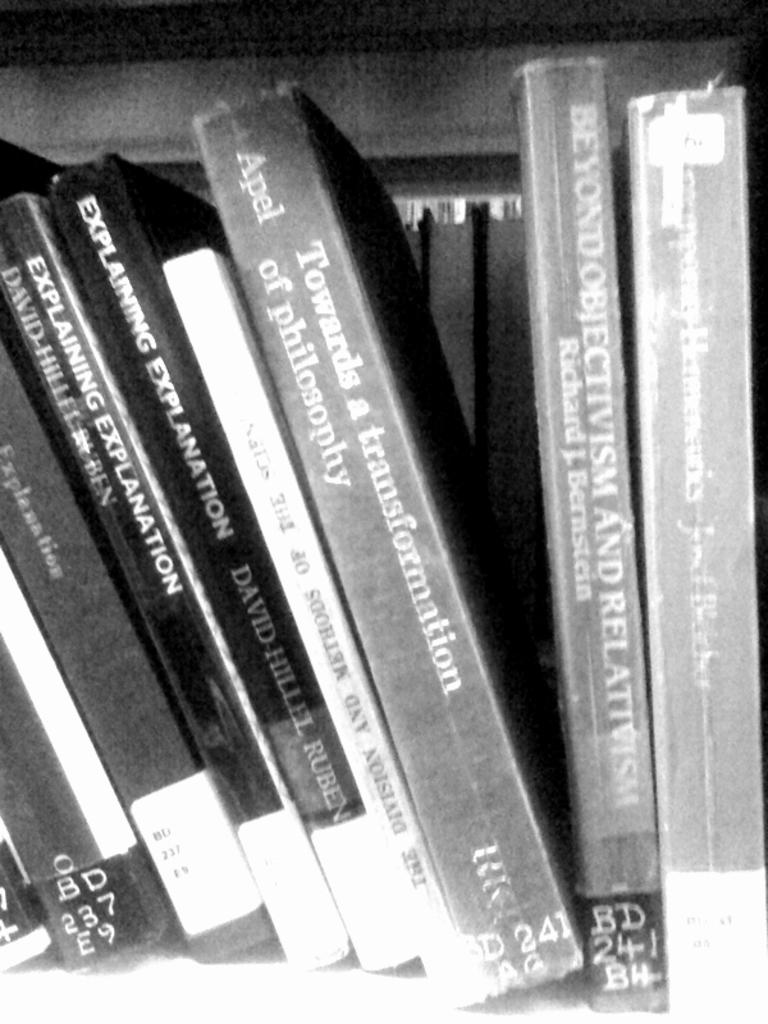<image>
Describe the image concisely. Towards a transformation and many other books on a shelf 